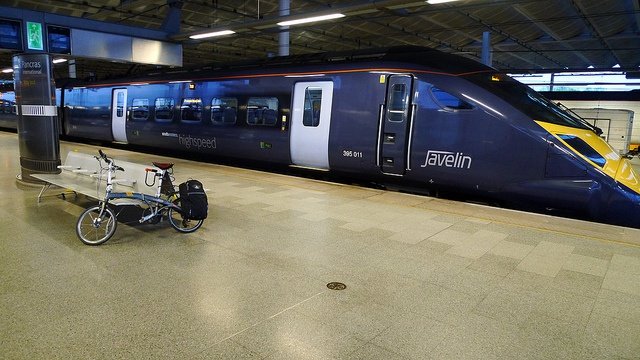Describe the objects in this image and their specific colors. I can see train in black, navy, lavender, and gray tones, bicycle in black, gray, darkgreen, and darkgray tones, bench in black, darkgray, gray, and lightgray tones, and backpack in black, gray, and darkgray tones in this image. 